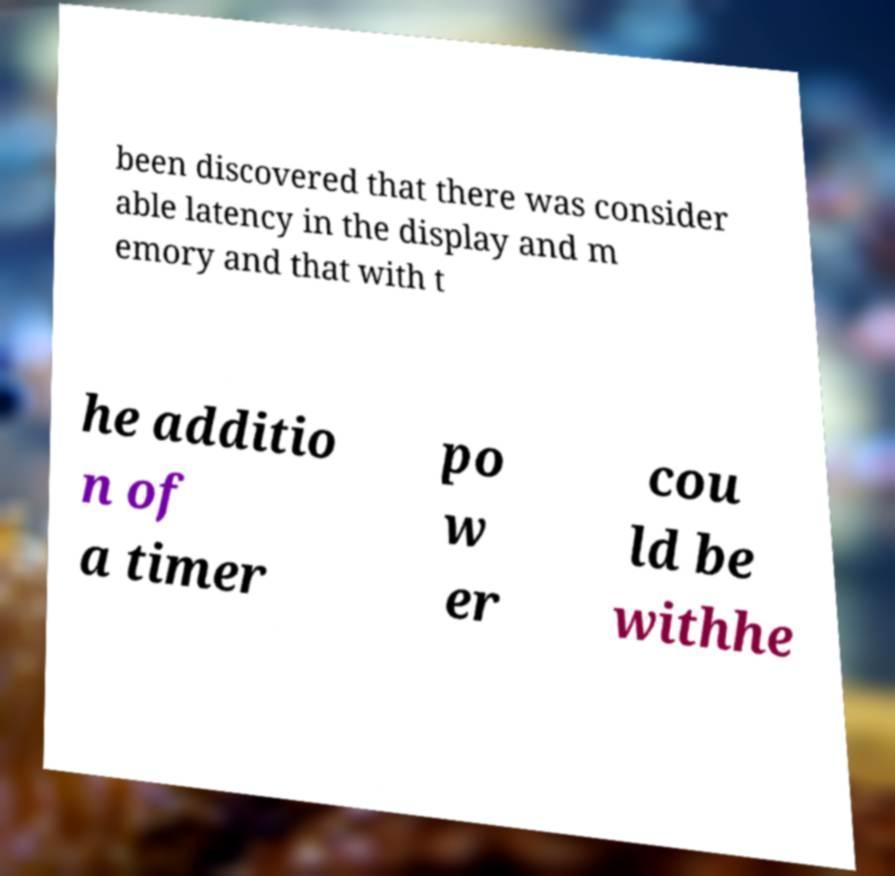What messages or text are displayed in this image? I need them in a readable, typed format. been discovered that there was consider able latency in the display and m emory and that with t he additio n of a timer po w er cou ld be withhe 